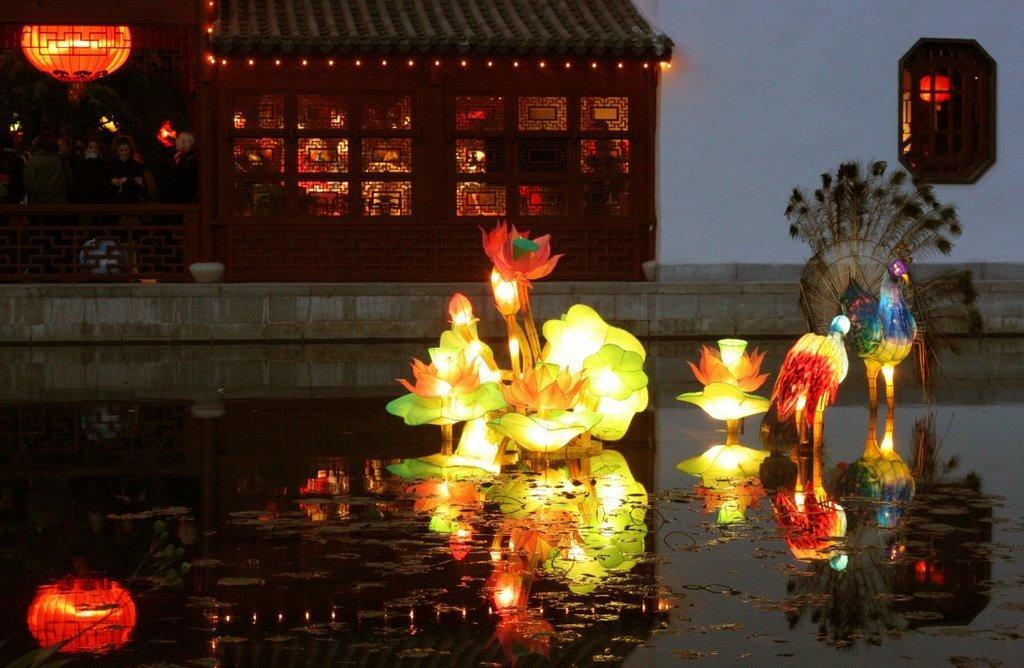Could you give a brief overview of what you see in this image? In the picture I can see light decoration items, I can see the water, the wall and house in the background. 